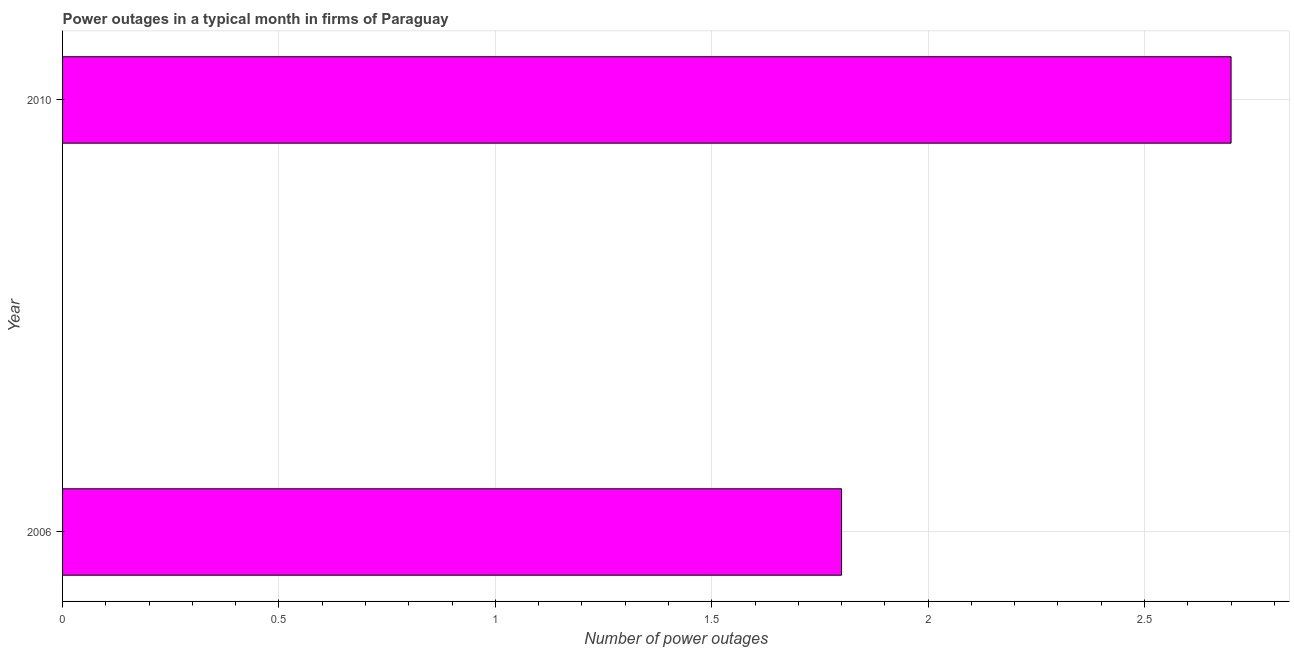What is the title of the graph?
Your answer should be very brief. Power outages in a typical month in firms of Paraguay. What is the label or title of the X-axis?
Ensure brevity in your answer.  Number of power outages. Across all years, what is the minimum number of power outages?
Ensure brevity in your answer.  1.8. In which year was the number of power outages maximum?
Ensure brevity in your answer.  2010. What is the average number of power outages per year?
Ensure brevity in your answer.  2.25. What is the median number of power outages?
Make the answer very short. 2.25. In how many years, is the number of power outages greater than 2.2 ?
Your answer should be very brief. 1. What is the ratio of the number of power outages in 2006 to that in 2010?
Ensure brevity in your answer.  0.67. Is the number of power outages in 2006 less than that in 2010?
Keep it short and to the point. Yes. In how many years, is the number of power outages greater than the average number of power outages taken over all years?
Your response must be concise. 1. How many bars are there?
Keep it short and to the point. 2. What is the difference between two consecutive major ticks on the X-axis?
Your answer should be very brief. 0.5. Are the values on the major ticks of X-axis written in scientific E-notation?
Provide a succinct answer. No. What is the Number of power outages of 2006?
Ensure brevity in your answer.  1.8. What is the Number of power outages of 2010?
Offer a terse response. 2.7. What is the ratio of the Number of power outages in 2006 to that in 2010?
Your response must be concise. 0.67. 